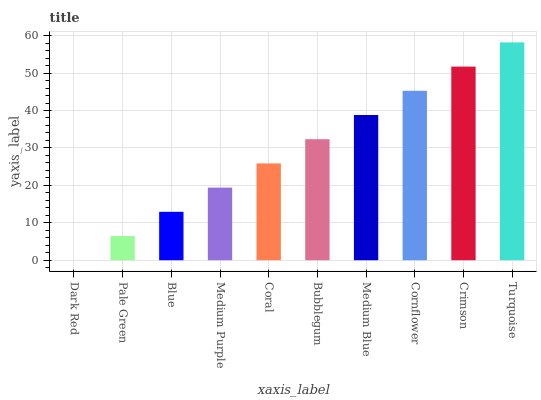Is Dark Red the minimum?
Answer yes or no. Yes. Is Turquoise the maximum?
Answer yes or no. Yes. Is Pale Green the minimum?
Answer yes or no. No. Is Pale Green the maximum?
Answer yes or no. No. Is Pale Green greater than Dark Red?
Answer yes or no. Yes. Is Dark Red less than Pale Green?
Answer yes or no. Yes. Is Dark Red greater than Pale Green?
Answer yes or no. No. Is Pale Green less than Dark Red?
Answer yes or no. No. Is Bubblegum the high median?
Answer yes or no. Yes. Is Coral the low median?
Answer yes or no. Yes. Is Cornflower the high median?
Answer yes or no. No. Is Pale Green the low median?
Answer yes or no. No. 